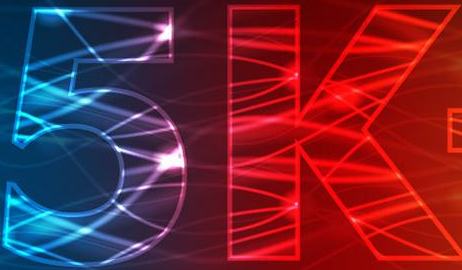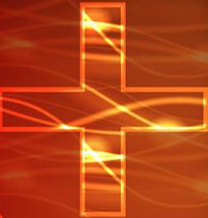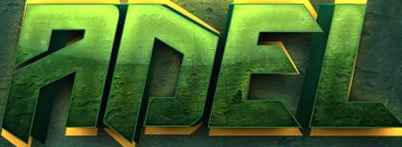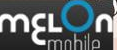What words are shown in these images in order, separated by a semicolon? 5k; +; ADEL; mɛLon 